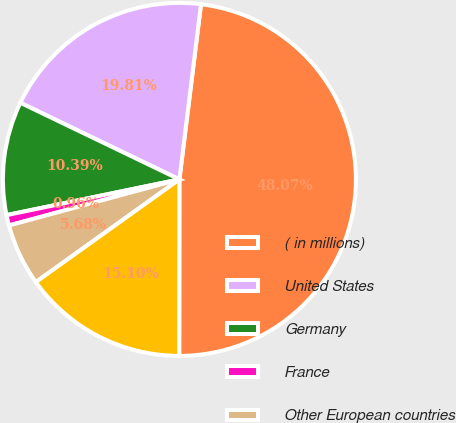Convert chart. <chart><loc_0><loc_0><loc_500><loc_500><pie_chart><fcel>( in millions)<fcel>United States<fcel>Germany<fcel>France<fcel>Other European countries<fcel>Other<nl><fcel>48.07%<fcel>19.81%<fcel>10.39%<fcel>0.96%<fcel>5.68%<fcel>15.1%<nl></chart> 